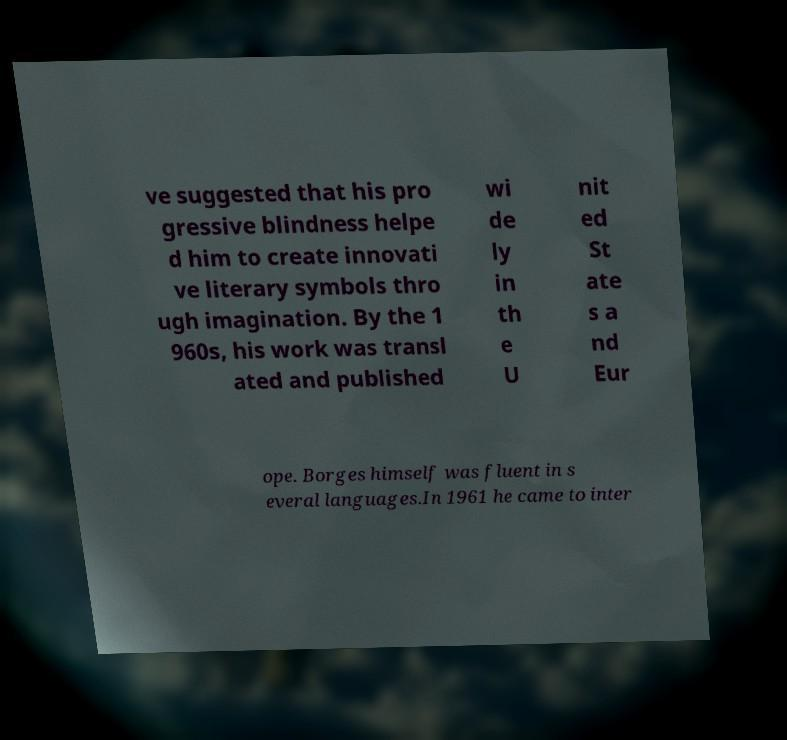Could you assist in decoding the text presented in this image and type it out clearly? ve suggested that his pro gressive blindness helpe d him to create innovati ve literary symbols thro ugh imagination. By the 1 960s, his work was transl ated and published wi de ly in th e U nit ed St ate s a nd Eur ope. Borges himself was fluent in s everal languages.In 1961 he came to inter 